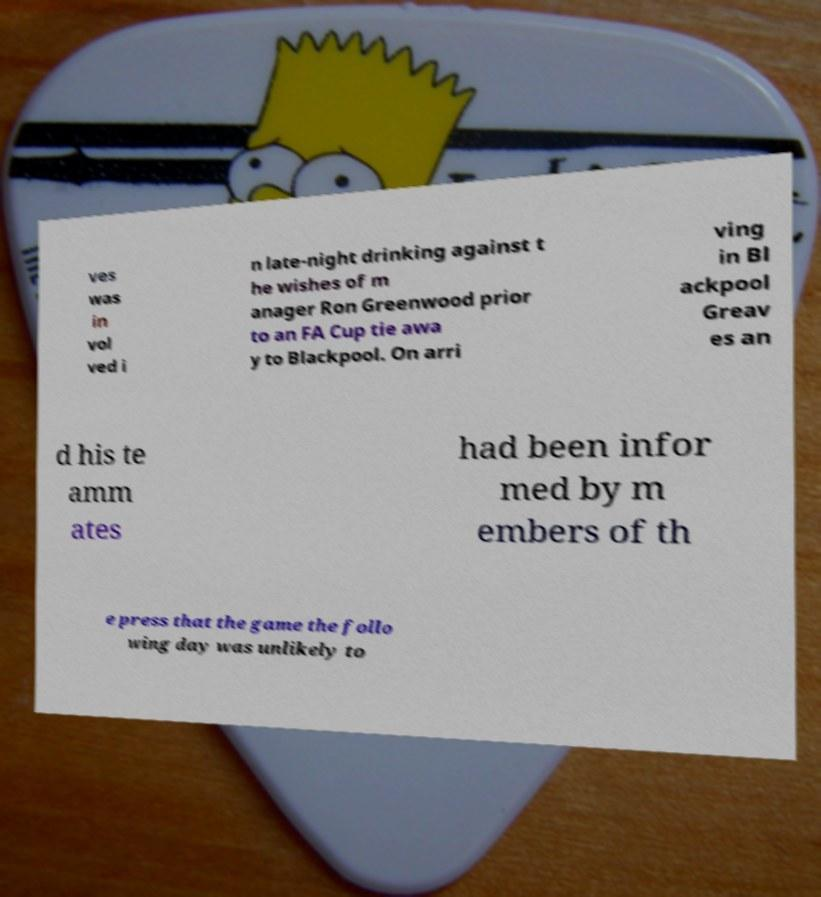There's text embedded in this image that I need extracted. Can you transcribe it verbatim? ves was in vol ved i n late-night drinking against t he wishes of m anager Ron Greenwood prior to an FA Cup tie awa y to Blackpool. On arri ving in Bl ackpool Greav es an d his te amm ates had been infor med by m embers of th e press that the game the follo wing day was unlikely to 